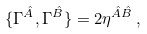<formula> <loc_0><loc_0><loc_500><loc_500>\{ \Gamma ^ { \hat { A } } , \Gamma ^ { \hat { B } } \} = 2 \eta ^ { \hat { A } \hat { B } } \, ,</formula> 